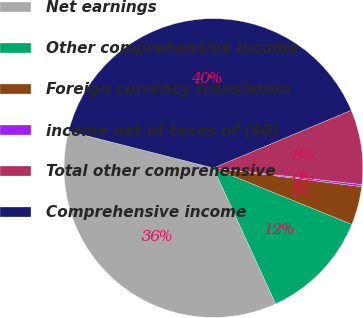Convert chart to OTSL. <chart><loc_0><loc_0><loc_500><loc_500><pie_chart><fcel>Net earnings<fcel>Other comprehensive income<fcel>Foreign currency translation<fcel>income net of taxes of (40)<fcel>Total other comprehensive<fcel>Comprehensive income<nl><fcel>35.8%<fcel>12.01%<fcel>4.16%<fcel>0.23%<fcel>8.08%<fcel>39.72%<nl></chart> 